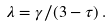Convert formula to latex. <formula><loc_0><loc_0><loc_500><loc_500>\lambda = \gamma / ( 3 - \tau ) \, .</formula> 